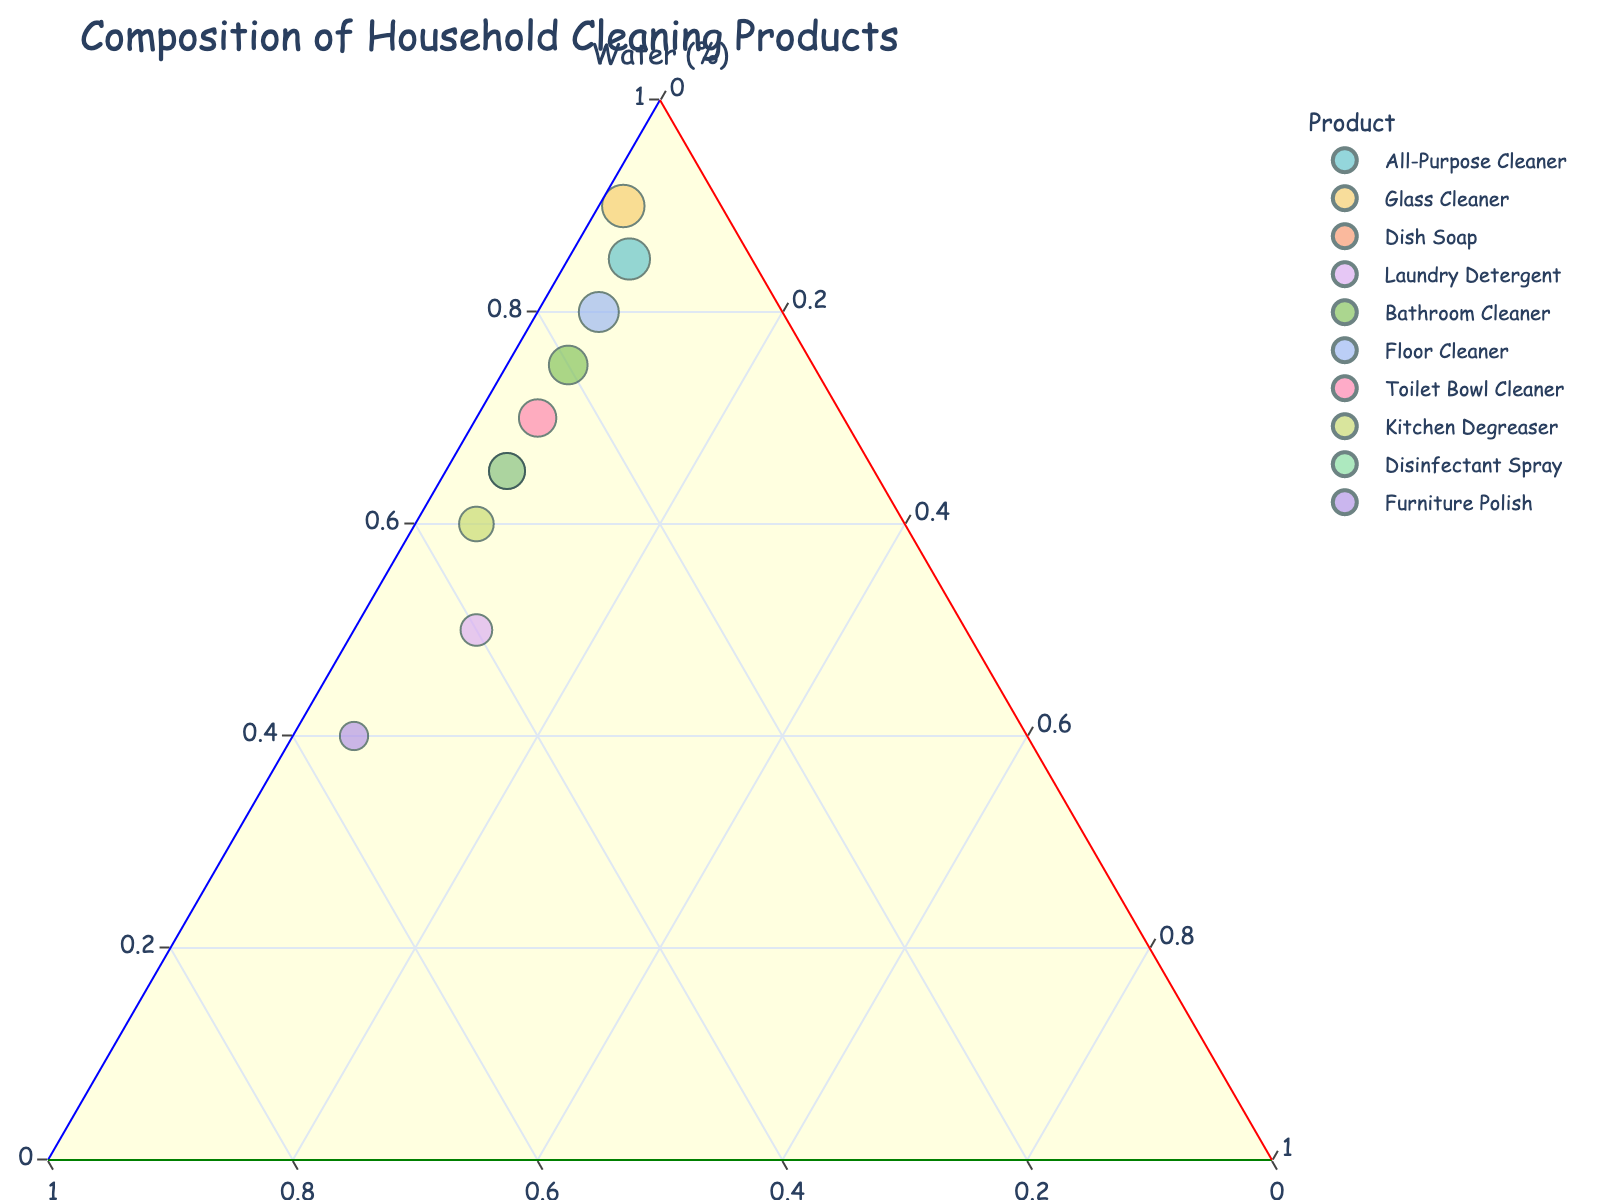How many data points are there for household cleaning products in the plot? Each product represents one data point in the plot. Given that there are 10 different products listed, there must be 10 data points in the plot.
Answer: 10 What is the title of the figure? The title of the figure is directly visible above the chart. It reads "Composition of Household Cleaning Products."
Answer: Composition of Household Cleaning Products Which household cleaning product has the highest percentage of active ingredients? By looking at the point that is closest to the axis labeled "Active Ingredients" with the highest percentage, we can see that Furniture Polish has the highest value with 55%.
Answer: Furniture Polish Which product has the smallest percentage of water? The point closest to the axis labeled "Water," indicating the lowest percentage, corresponds to Furniture Polish, which has 40% water.
Answer: Furniture Polish What are the three components shown in the ternary plot? The ternary plot displays three components, with each axis representing one of these: Water (%), Active Ingredients (%), and Other Additives (%).
Answer: Water, Active Ingredients, Other Additives Which two products have an equal percentage of other additives? By observing the plot, we see that multiple points align horizontally at the same level on the axis for "Other Additives." The products with 5% Other Additives are All-Purpose Cleaner, Dish Soap, Bathroom Cleaner, Floor Cleaner, Toilet Bowl Cleaner, Kitchen Degreaser, Disinfectant Spray, and Furniture Polish.
Answer: All-Purpose Cleaner, Dish Soap, Bathroom Cleaner, Floor Cleaner, Toilet Bowl Cleaner, Kitchen Degreaser, Disinfectant Spray, Furniture Polish What is the percentage difference in active ingredients between Kitchen Degreaser and Glass Cleaner? Kitchen Degreaser has 35% active ingredients, and Glass Cleaner has 8%. The difference is 35% - 8% = 27%.
Answer: 27% Which product has a higher water percentage: Toilet Bowl Cleaner or Disinfectant Spray? By comparing the positions on the plot along the "Water (%)" axis, we see that the Toilet Bowl Cleaner has 70% water, while Disinfectant Spray has 65%. Therefore, Toilet Bowl Cleaner has a higher percentage.
Answer: Toilet Bowl Cleaner Is there a product with equal parts water and active ingredients? By examining the positions on the plot and their respective percentage labels, none of the products have equal percentages of water and active ingredients.
Answer: No 